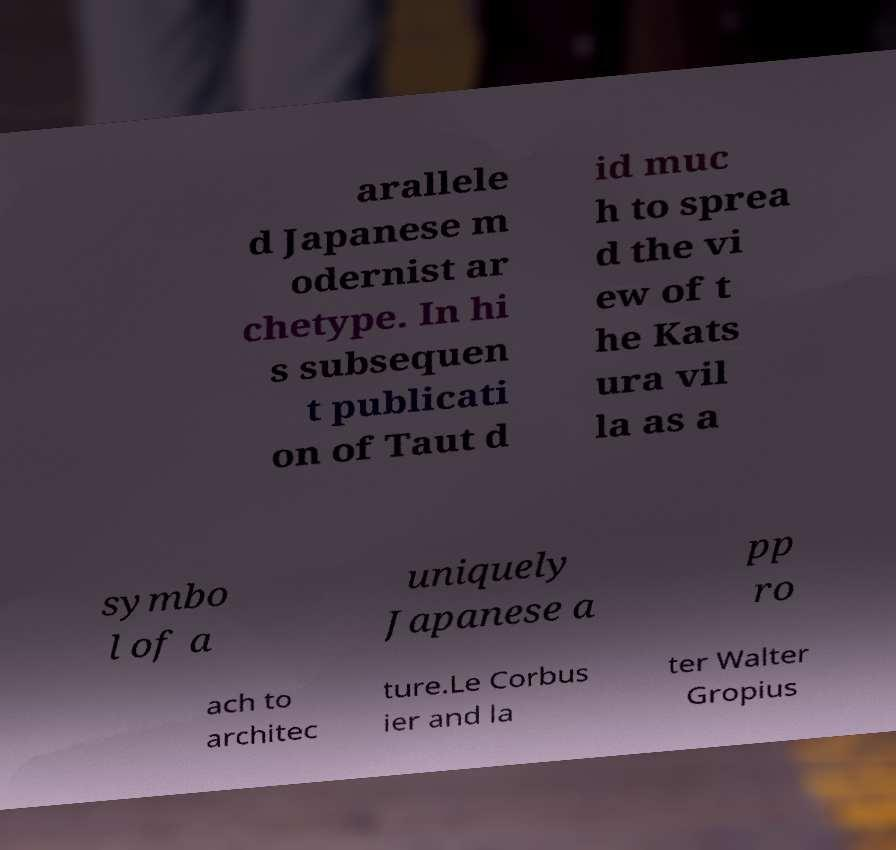For documentation purposes, I need the text within this image transcribed. Could you provide that? arallele d Japanese m odernist ar chetype. In hi s subsequen t publicati on of Taut d id muc h to sprea d the vi ew of t he Kats ura vil la as a symbo l of a uniquely Japanese a pp ro ach to architec ture.Le Corbus ier and la ter Walter Gropius 